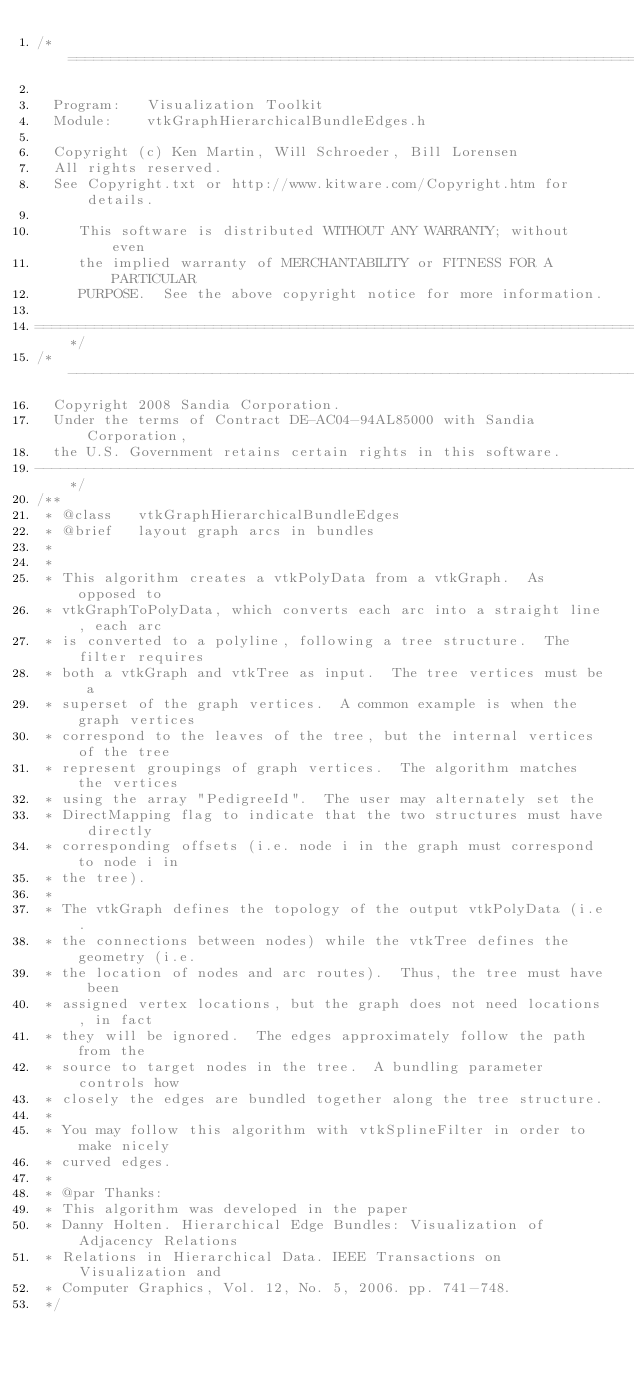<code> <loc_0><loc_0><loc_500><loc_500><_C_>/*=========================================================================

  Program:   Visualization Toolkit
  Module:    vtkGraphHierarchicalBundleEdges.h

  Copyright (c) Ken Martin, Will Schroeder, Bill Lorensen
  All rights reserved.
  See Copyright.txt or http://www.kitware.com/Copyright.htm for details.

     This software is distributed WITHOUT ANY WARRANTY; without even
     the implied warranty of MERCHANTABILITY or FITNESS FOR A PARTICULAR
     PURPOSE.  See the above copyright notice for more information.

=========================================================================*/
/*-------------------------------------------------------------------------
  Copyright 2008 Sandia Corporation.
  Under the terms of Contract DE-AC04-94AL85000 with Sandia Corporation,
  the U.S. Government retains certain rights in this software.
-------------------------------------------------------------------------*/
/**
 * @class   vtkGraphHierarchicalBundleEdges
 * @brief   layout graph arcs in bundles
 *
 *
 * This algorithm creates a vtkPolyData from a vtkGraph.  As opposed to
 * vtkGraphToPolyData, which converts each arc into a straight line, each arc
 * is converted to a polyline, following a tree structure.  The filter requires
 * both a vtkGraph and vtkTree as input.  The tree vertices must be a
 * superset of the graph vertices.  A common example is when the graph vertices
 * correspond to the leaves of the tree, but the internal vertices of the tree
 * represent groupings of graph vertices.  The algorithm matches the vertices
 * using the array "PedigreeId".  The user may alternately set the
 * DirectMapping flag to indicate that the two structures must have directly
 * corresponding offsets (i.e. node i in the graph must correspond to node i in
 * the tree).
 *
 * The vtkGraph defines the topology of the output vtkPolyData (i.e.
 * the connections between nodes) while the vtkTree defines the geometry (i.e.
 * the location of nodes and arc routes).  Thus, the tree must have been
 * assigned vertex locations, but the graph does not need locations, in fact
 * they will be ignored.  The edges approximately follow the path from the
 * source to target nodes in the tree.  A bundling parameter controls how
 * closely the edges are bundled together along the tree structure.
 *
 * You may follow this algorithm with vtkSplineFilter in order to make nicely
 * curved edges.
 *
 * @par Thanks:
 * This algorithm was developed in the paper
 * Danny Holten. Hierarchical Edge Bundles: Visualization of Adjacency Relations
 * Relations in Hierarchical Data. IEEE Transactions on Visualization and
 * Computer Graphics, Vol. 12, No. 5, 2006. pp. 741-748.
 */
</code> 